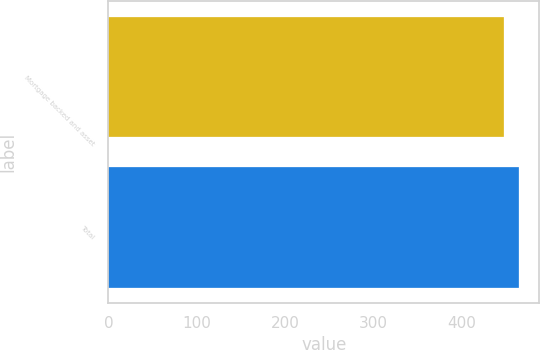<chart> <loc_0><loc_0><loc_500><loc_500><bar_chart><fcel>Mortgage backed and asset<fcel>Total<nl><fcel>448<fcel>464<nl></chart> 